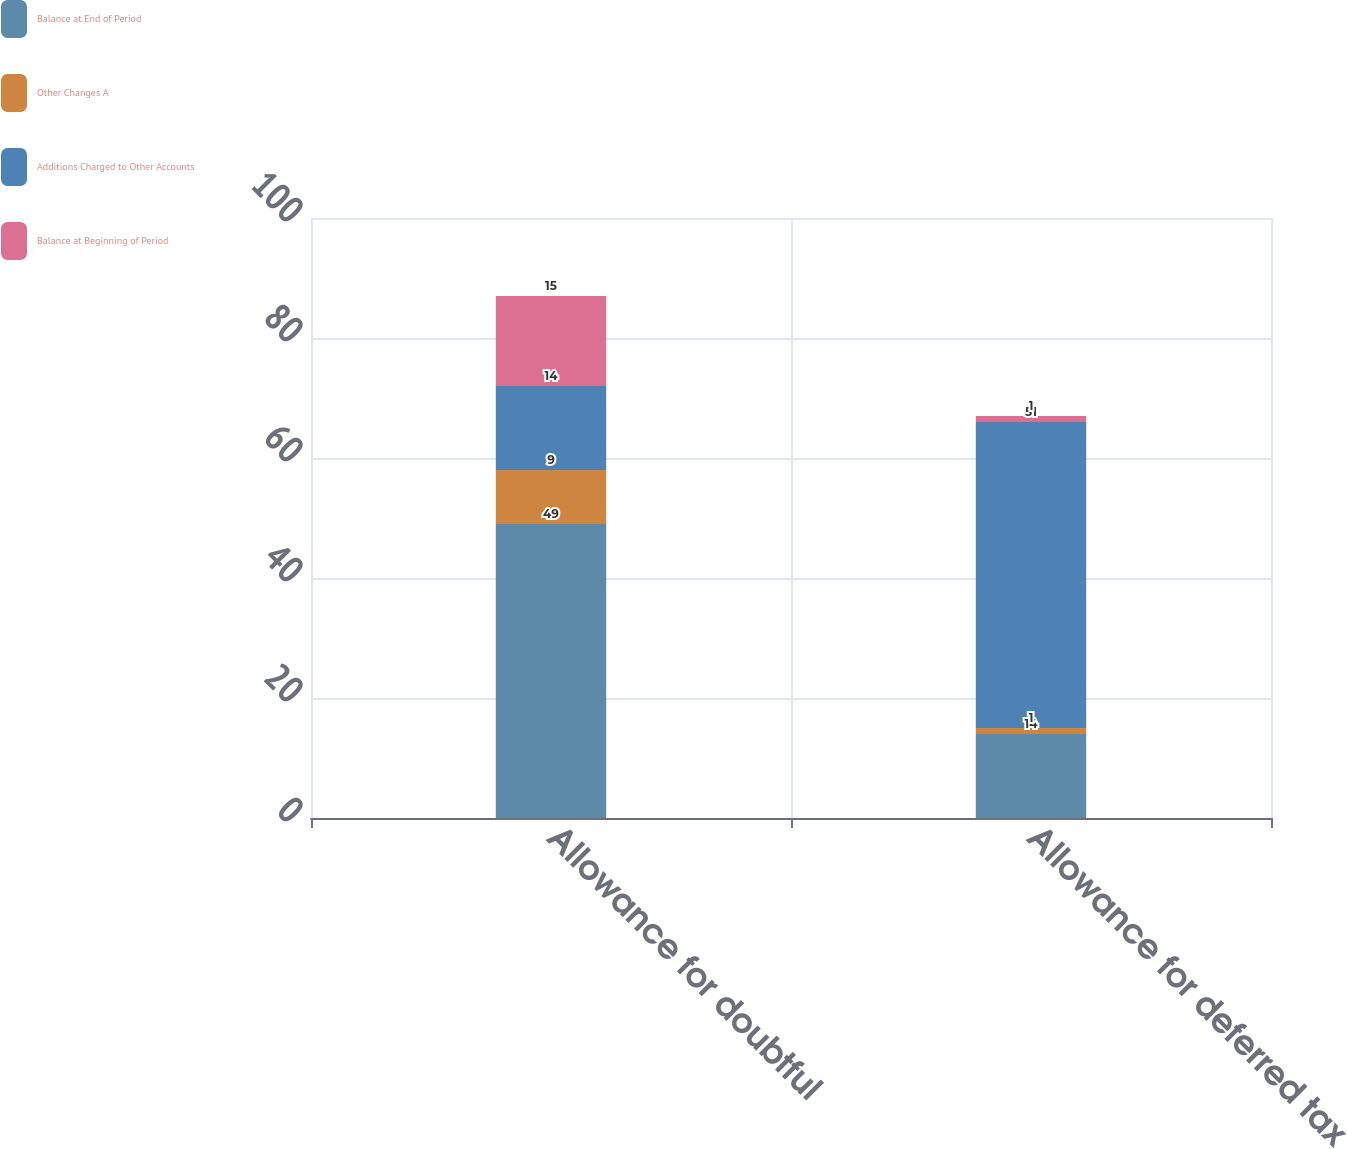<chart> <loc_0><loc_0><loc_500><loc_500><stacked_bar_chart><ecel><fcel>Allowance for doubtful<fcel>Allowance for deferred tax<nl><fcel>Balance at End of Period<fcel>49<fcel>14<nl><fcel>Other Changes A<fcel>9<fcel>1<nl><fcel>Additions Charged to Other Accounts<fcel>14<fcel>51<nl><fcel>Balance at Beginning of Period<fcel>15<fcel>1<nl></chart> 